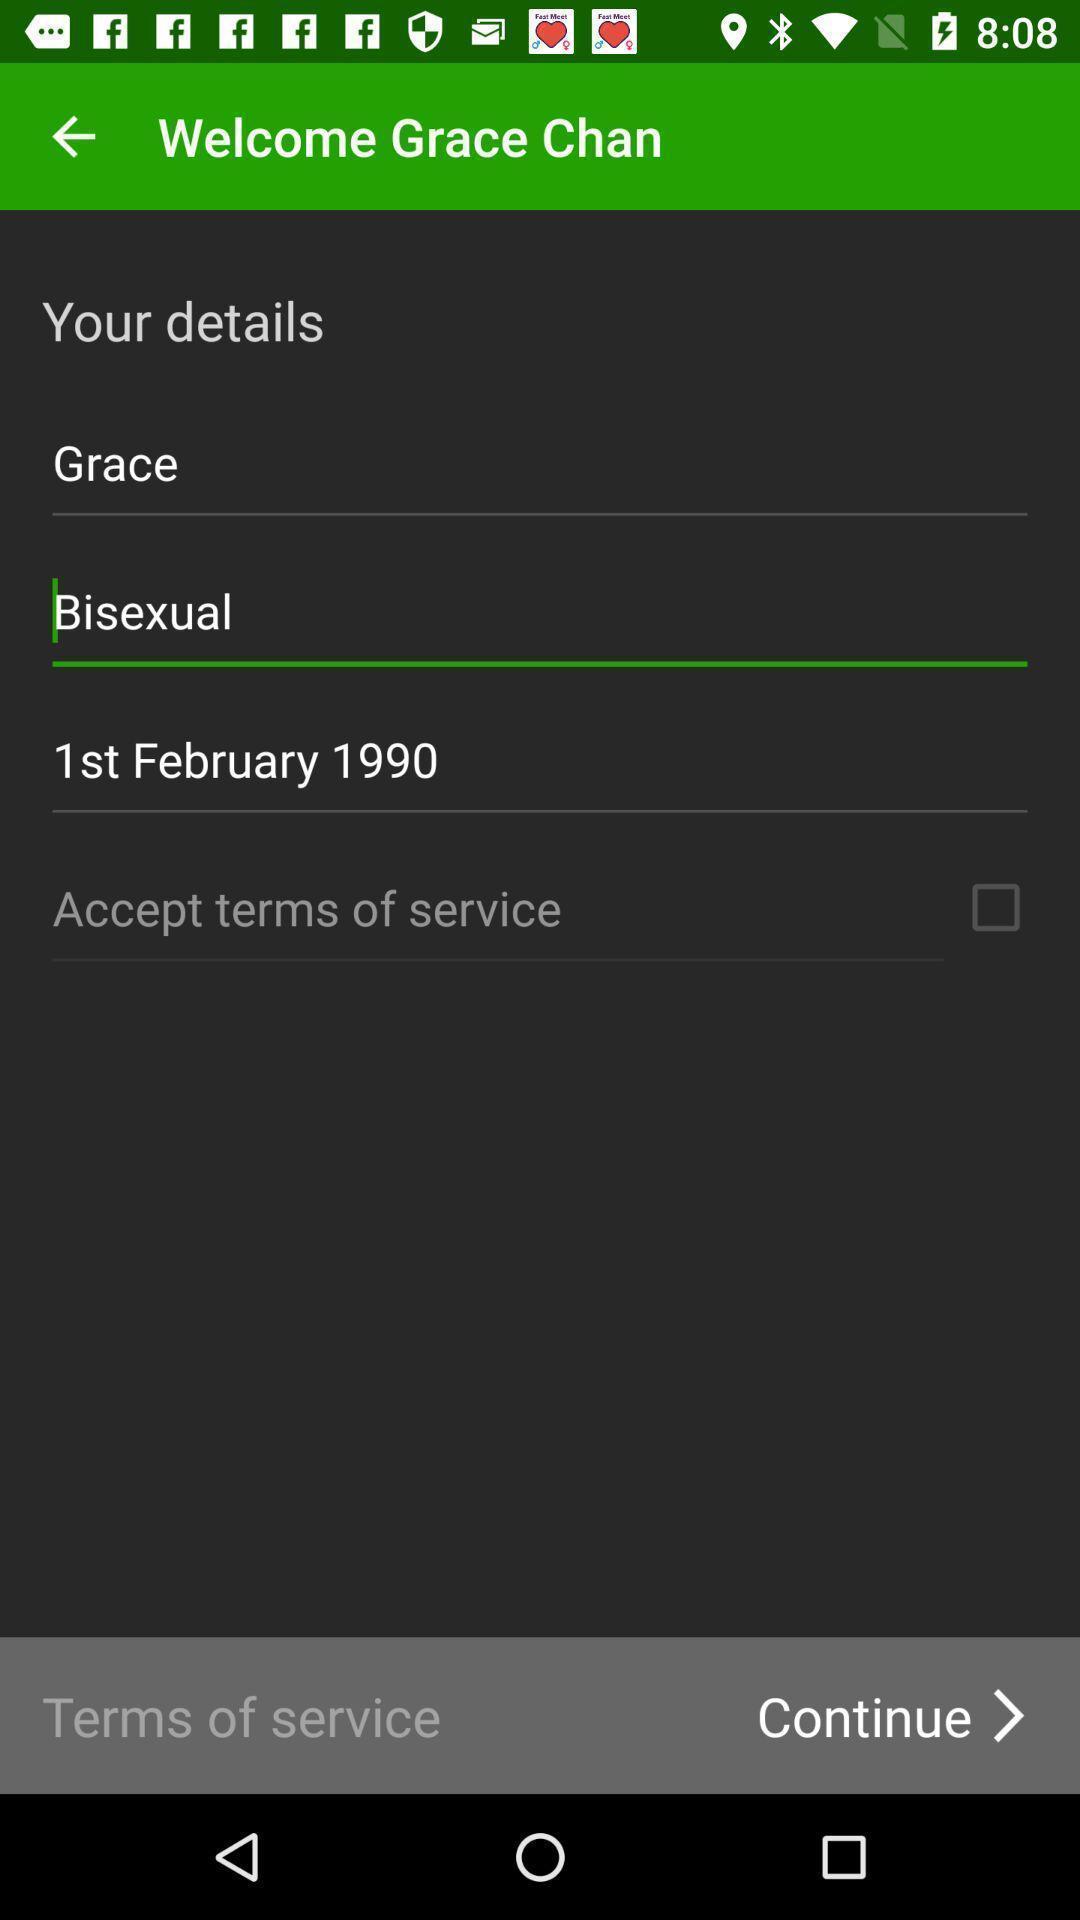Provide a description of this screenshot. Welcome page of social app. 